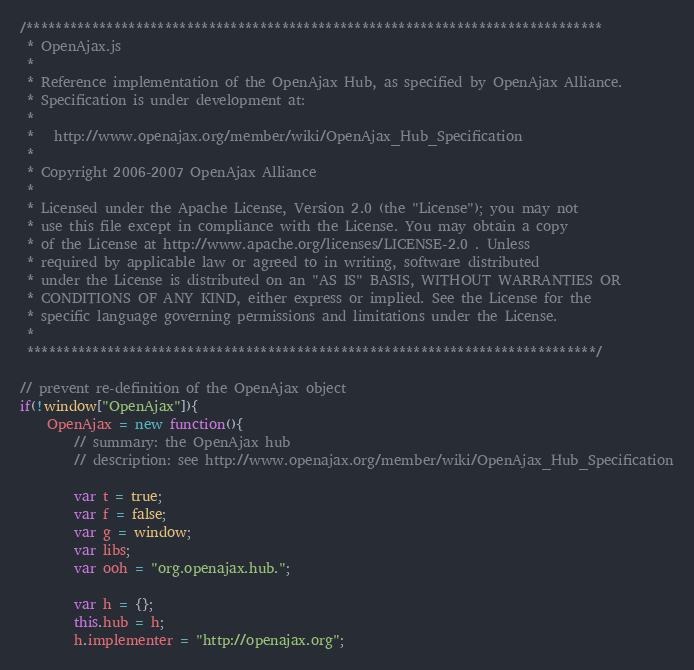Convert code to text. <code><loc_0><loc_0><loc_500><loc_500><_JavaScript_>/*******************************************************************************
 * OpenAjax.js
 *
 * Reference implementation of the OpenAjax Hub, as specified by OpenAjax Alliance.
 * Specification is under development at:
 *
 *   http://www.openajax.org/member/wiki/OpenAjax_Hub_Specification
 *
 * Copyright 2006-2007 OpenAjax Alliance
 *
 * Licensed under the Apache License, Version 2.0 (the "License"); you may not
 * use this file except in compliance with the License. You may obtain a copy
 * of the License at http://www.apache.org/licenses/LICENSE-2.0 . Unless
 * required by applicable law or agreed to in writing, software distributed
 * under the License is distributed on an "AS IS" BASIS, WITHOUT WARRANTIES OR
 * CONDITIONS OF ANY KIND, either express or implied. See the License for the
 * specific language governing permissions and limitations under the License.
 *
 ******************************************************************************/

// prevent re-definition of the OpenAjax object
if(!window["OpenAjax"]){
	OpenAjax = new function(){
		// summary: the OpenAjax hub
		// description: see http://www.openajax.org/member/wiki/OpenAjax_Hub_Specification

		var t = true;
		var f = false;
		var g = window;
		var libs;
		var ooh = "org.openajax.hub.";

		var h = {};
		this.hub = h;
		h.implementer = "http://openajax.org";</code> 